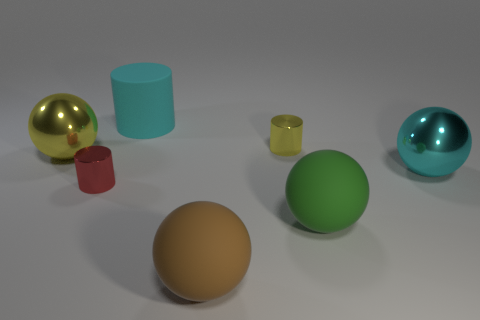How many other objects are there of the same size as the green rubber object?
Ensure brevity in your answer.  4. There is a ball that is on the left side of the big cylinder; does it have the same size as the shiny cylinder that is behind the red shiny thing?
Offer a very short reply. No. What number of big metal things have the same color as the large cylinder?
Offer a very short reply. 1. What number of small objects are cyan shiny spheres or rubber spheres?
Keep it short and to the point. 0. Does the cylinder on the right side of the cyan matte object have the same material as the small red cylinder?
Make the answer very short. Yes. What color is the rubber object behind the green matte object?
Offer a very short reply. Cyan. Are there any gray things that have the same size as the yellow metal ball?
Provide a succinct answer. No. There is a cyan cylinder that is the same size as the green object; what is it made of?
Offer a terse response. Rubber. Is the size of the cyan matte thing the same as the cylinder to the left of the big cyan matte cylinder?
Ensure brevity in your answer.  No. There is a ball that is to the right of the green object; what is it made of?
Keep it short and to the point. Metal. 